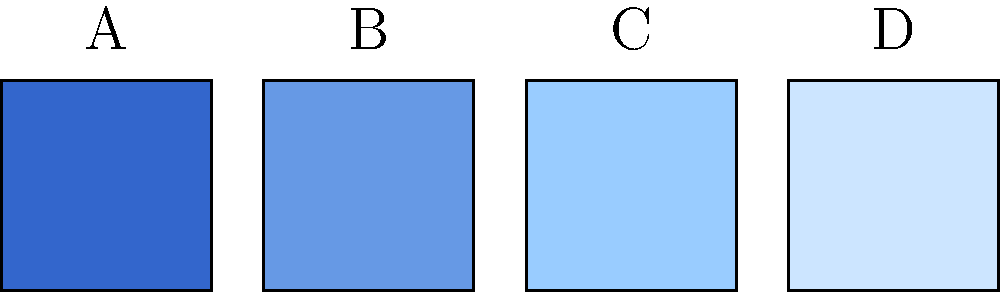Which color scheme would be most suitable for an open source organization's brand logo, considering the principles of color harmony and the values typically associated with open source? To determine the most harmonious color scheme for an open source organization's brand logo, we need to consider several factors:

1. Color psychology: Blues are often associated with trust, stability, and professionalism, which align well with open source values.

2. Color harmony: The color scheme shows a monochromatic palette of blues, which is harmonious and pleasing to the eye.

3. Contrast: There's a gradual progression from darker to lighter shades, providing good contrast and readability.

4. Open source values: The color scheme should reflect openness, collaboration, and innovation.

5. Versatility: The palette should work well across various marketing materials and digital platforms.

Analyzing the options:

A: The darkest blue - While professional, it might be too somber for an open source brand.
B: A medium-dark blue - This provides a good balance of professionalism and approachability.
C: A medium-light blue - This shade is friendly and inviting, aligning well with open source ideals.
D: The lightest blue - While fresh, it might lack the depth needed for a primary brand color.

Considering these factors, option B or C would be the most suitable primary colors for the logo. They provide a good balance of professionalism, approachability, and alignment with open source values. The other shades could be used as secondary colors in the overall brand palette.

Given the open source context, which often emphasizes community and collaboration, option C (the medium-light blue) would be the most harmonious choice. It's friendly and inviting while still maintaining a professional appearance.
Answer: C (medium-light blue) 